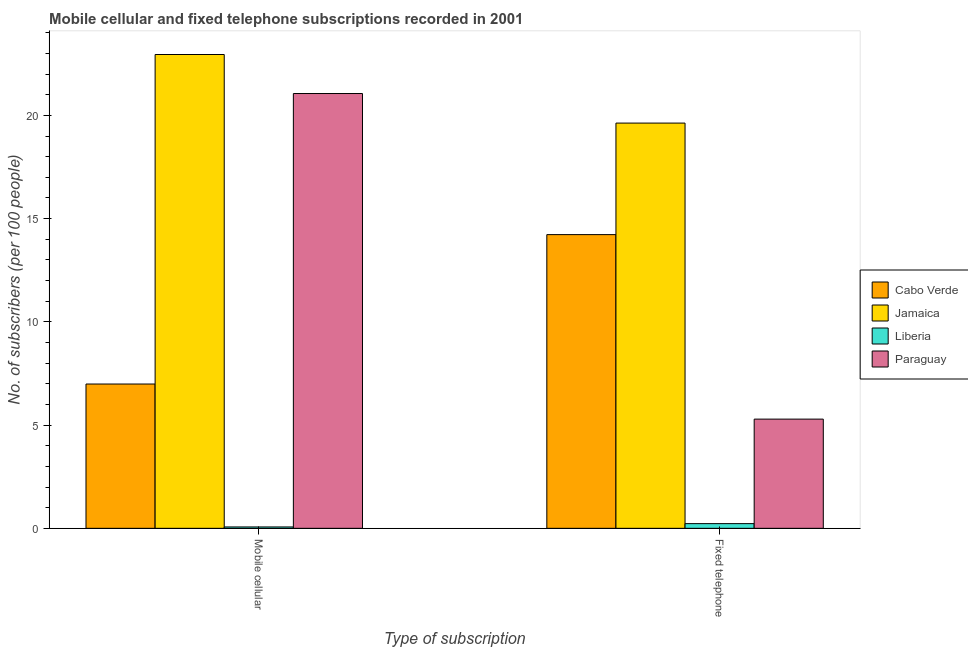How many groups of bars are there?
Your answer should be compact. 2. Are the number of bars on each tick of the X-axis equal?
Ensure brevity in your answer.  Yes. What is the label of the 1st group of bars from the left?
Ensure brevity in your answer.  Mobile cellular. What is the number of mobile cellular subscribers in Paraguay?
Your answer should be very brief. 21.06. Across all countries, what is the maximum number of mobile cellular subscribers?
Offer a terse response. 22.95. Across all countries, what is the minimum number of fixed telephone subscribers?
Ensure brevity in your answer.  0.23. In which country was the number of mobile cellular subscribers maximum?
Your response must be concise. Jamaica. In which country was the number of fixed telephone subscribers minimum?
Offer a terse response. Liberia. What is the total number of mobile cellular subscribers in the graph?
Offer a terse response. 51.07. What is the difference between the number of mobile cellular subscribers in Jamaica and that in Liberia?
Your answer should be compact. 22.88. What is the difference between the number of fixed telephone subscribers in Liberia and the number of mobile cellular subscribers in Jamaica?
Offer a terse response. -22.72. What is the average number of mobile cellular subscribers per country?
Provide a short and direct response. 12.77. What is the difference between the number of fixed telephone subscribers and number of mobile cellular subscribers in Liberia?
Provide a short and direct response. 0.16. In how many countries, is the number of fixed telephone subscribers greater than 2 ?
Provide a short and direct response. 3. What is the ratio of the number of fixed telephone subscribers in Jamaica to that in Liberia?
Provide a short and direct response. 86.56. Is the number of fixed telephone subscribers in Cabo Verde less than that in Paraguay?
Keep it short and to the point. No. In how many countries, is the number of fixed telephone subscribers greater than the average number of fixed telephone subscribers taken over all countries?
Your response must be concise. 2. What does the 1st bar from the left in Mobile cellular represents?
Offer a terse response. Cabo Verde. What does the 1st bar from the right in Fixed telephone represents?
Offer a terse response. Paraguay. Are all the bars in the graph horizontal?
Provide a succinct answer. No. Are the values on the major ticks of Y-axis written in scientific E-notation?
Your answer should be very brief. No. How are the legend labels stacked?
Ensure brevity in your answer.  Vertical. What is the title of the graph?
Your response must be concise. Mobile cellular and fixed telephone subscriptions recorded in 2001. What is the label or title of the X-axis?
Your response must be concise. Type of subscription. What is the label or title of the Y-axis?
Your answer should be compact. No. of subscribers (per 100 people). What is the No. of subscribers (per 100 people) in Cabo Verde in Mobile cellular?
Your answer should be very brief. 6.99. What is the No. of subscribers (per 100 people) of Jamaica in Mobile cellular?
Your answer should be compact. 22.95. What is the No. of subscribers (per 100 people) of Liberia in Mobile cellular?
Make the answer very short. 0.07. What is the No. of subscribers (per 100 people) of Paraguay in Mobile cellular?
Make the answer very short. 21.06. What is the No. of subscribers (per 100 people) of Cabo Verde in Fixed telephone?
Ensure brevity in your answer.  14.23. What is the No. of subscribers (per 100 people) in Jamaica in Fixed telephone?
Your response must be concise. 19.63. What is the No. of subscribers (per 100 people) in Liberia in Fixed telephone?
Your response must be concise. 0.23. What is the No. of subscribers (per 100 people) of Paraguay in Fixed telephone?
Your answer should be compact. 5.29. Across all Type of subscription, what is the maximum No. of subscribers (per 100 people) in Cabo Verde?
Offer a very short reply. 14.23. Across all Type of subscription, what is the maximum No. of subscribers (per 100 people) in Jamaica?
Give a very brief answer. 22.95. Across all Type of subscription, what is the maximum No. of subscribers (per 100 people) of Liberia?
Make the answer very short. 0.23. Across all Type of subscription, what is the maximum No. of subscribers (per 100 people) in Paraguay?
Your answer should be very brief. 21.06. Across all Type of subscription, what is the minimum No. of subscribers (per 100 people) of Cabo Verde?
Provide a succinct answer. 6.99. Across all Type of subscription, what is the minimum No. of subscribers (per 100 people) in Jamaica?
Offer a very short reply. 19.63. Across all Type of subscription, what is the minimum No. of subscribers (per 100 people) of Liberia?
Give a very brief answer. 0.07. Across all Type of subscription, what is the minimum No. of subscribers (per 100 people) of Paraguay?
Your answer should be compact. 5.29. What is the total No. of subscribers (per 100 people) in Cabo Verde in the graph?
Keep it short and to the point. 21.21. What is the total No. of subscribers (per 100 people) of Jamaica in the graph?
Offer a terse response. 42.58. What is the total No. of subscribers (per 100 people) of Liberia in the graph?
Offer a very short reply. 0.29. What is the total No. of subscribers (per 100 people) of Paraguay in the graph?
Your answer should be compact. 26.35. What is the difference between the No. of subscribers (per 100 people) in Cabo Verde in Mobile cellular and that in Fixed telephone?
Ensure brevity in your answer.  -7.24. What is the difference between the No. of subscribers (per 100 people) in Jamaica in Mobile cellular and that in Fixed telephone?
Offer a very short reply. 3.32. What is the difference between the No. of subscribers (per 100 people) in Liberia in Mobile cellular and that in Fixed telephone?
Provide a short and direct response. -0.16. What is the difference between the No. of subscribers (per 100 people) of Paraguay in Mobile cellular and that in Fixed telephone?
Keep it short and to the point. 15.77. What is the difference between the No. of subscribers (per 100 people) in Cabo Verde in Mobile cellular and the No. of subscribers (per 100 people) in Jamaica in Fixed telephone?
Your answer should be compact. -12.64. What is the difference between the No. of subscribers (per 100 people) in Cabo Verde in Mobile cellular and the No. of subscribers (per 100 people) in Liberia in Fixed telephone?
Your answer should be compact. 6.76. What is the difference between the No. of subscribers (per 100 people) of Cabo Verde in Mobile cellular and the No. of subscribers (per 100 people) of Paraguay in Fixed telephone?
Make the answer very short. 1.7. What is the difference between the No. of subscribers (per 100 people) of Jamaica in Mobile cellular and the No. of subscribers (per 100 people) of Liberia in Fixed telephone?
Offer a very short reply. 22.72. What is the difference between the No. of subscribers (per 100 people) in Jamaica in Mobile cellular and the No. of subscribers (per 100 people) in Paraguay in Fixed telephone?
Your answer should be very brief. 17.66. What is the difference between the No. of subscribers (per 100 people) of Liberia in Mobile cellular and the No. of subscribers (per 100 people) of Paraguay in Fixed telephone?
Offer a terse response. -5.22. What is the average No. of subscribers (per 100 people) in Cabo Verde per Type of subscription?
Your answer should be very brief. 10.61. What is the average No. of subscribers (per 100 people) in Jamaica per Type of subscription?
Provide a short and direct response. 21.29. What is the average No. of subscribers (per 100 people) in Liberia per Type of subscription?
Your answer should be compact. 0.15. What is the average No. of subscribers (per 100 people) in Paraguay per Type of subscription?
Provide a short and direct response. 13.17. What is the difference between the No. of subscribers (per 100 people) of Cabo Verde and No. of subscribers (per 100 people) of Jamaica in Mobile cellular?
Offer a terse response. -15.96. What is the difference between the No. of subscribers (per 100 people) of Cabo Verde and No. of subscribers (per 100 people) of Liberia in Mobile cellular?
Your answer should be very brief. 6.92. What is the difference between the No. of subscribers (per 100 people) in Cabo Verde and No. of subscribers (per 100 people) in Paraguay in Mobile cellular?
Provide a short and direct response. -14.07. What is the difference between the No. of subscribers (per 100 people) in Jamaica and No. of subscribers (per 100 people) in Liberia in Mobile cellular?
Your response must be concise. 22.88. What is the difference between the No. of subscribers (per 100 people) of Jamaica and No. of subscribers (per 100 people) of Paraguay in Mobile cellular?
Keep it short and to the point. 1.89. What is the difference between the No. of subscribers (per 100 people) in Liberia and No. of subscribers (per 100 people) in Paraguay in Mobile cellular?
Your answer should be compact. -20.99. What is the difference between the No. of subscribers (per 100 people) of Cabo Verde and No. of subscribers (per 100 people) of Jamaica in Fixed telephone?
Your response must be concise. -5.4. What is the difference between the No. of subscribers (per 100 people) in Cabo Verde and No. of subscribers (per 100 people) in Liberia in Fixed telephone?
Give a very brief answer. 14. What is the difference between the No. of subscribers (per 100 people) of Cabo Verde and No. of subscribers (per 100 people) of Paraguay in Fixed telephone?
Your response must be concise. 8.94. What is the difference between the No. of subscribers (per 100 people) of Jamaica and No. of subscribers (per 100 people) of Liberia in Fixed telephone?
Give a very brief answer. 19.4. What is the difference between the No. of subscribers (per 100 people) of Jamaica and No. of subscribers (per 100 people) of Paraguay in Fixed telephone?
Your answer should be very brief. 14.34. What is the difference between the No. of subscribers (per 100 people) in Liberia and No. of subscribers (per 100 people) in Paraguay in Fixed telephone?
Give a very brief answer. -5.06. What is the ratio of the No. of subscribers (per 100 people) of Cabo Verde in Mobile cellular to that in Fixed telephone?
Offer a terse response. 0.49. What is the ratio of the No. of subscribers (per 100 people) of Jamaica in Mobile cellular to that in Fixed telephone?
Ensure brevity in your answer.  1.17. What is the ratio of the No. of subscribers (per 100 people) of Liberia in Mobile cellular to that in Fixed telephone?
Your answer should be very brief. 0.29. What is the ratio of the No. of subscribers (per 100 people) in Paraguay in Mobile cellular to that in Fixed telephone?
Provide a succinct answer. 3.98. What is the difference between the highest and the second highest No. of subscribers (per 100 people) of Cabo Verde?
Offer a terse response. 7.24. What is the difference between the highest and the second highest No. of subscribers (per 100 people) in Jamaica?
Keep it short and to the point. 3.32. What is the difference between the highest and the second highest No. of subscribers (per 100 people) in Liberia?
Offer a terse response. 0.16. What is the difference between the highest and the second highest No. of subscribers (per 100 people) in Paraguay?
Give a very brief answer. 15.77. What is the difference between the highest and the lowest No. of subscribers (per 100 people) of Cabo Verde?
Your response must be concise. 7.24. What is the difference between the highest and the lowest No. of subscribers (per 100 people) in Jamaica?
Give a very brief answer. 3.32. What is the difference between the highest and the lowest No. of subscribers (per 100 people) in Liberia?
Your response must be concise. 0.16. What is the difference between the highest and the lowest No. of subscribers (per 100 people) in Paraguay?
Keep it short and to the point. 15.77. 